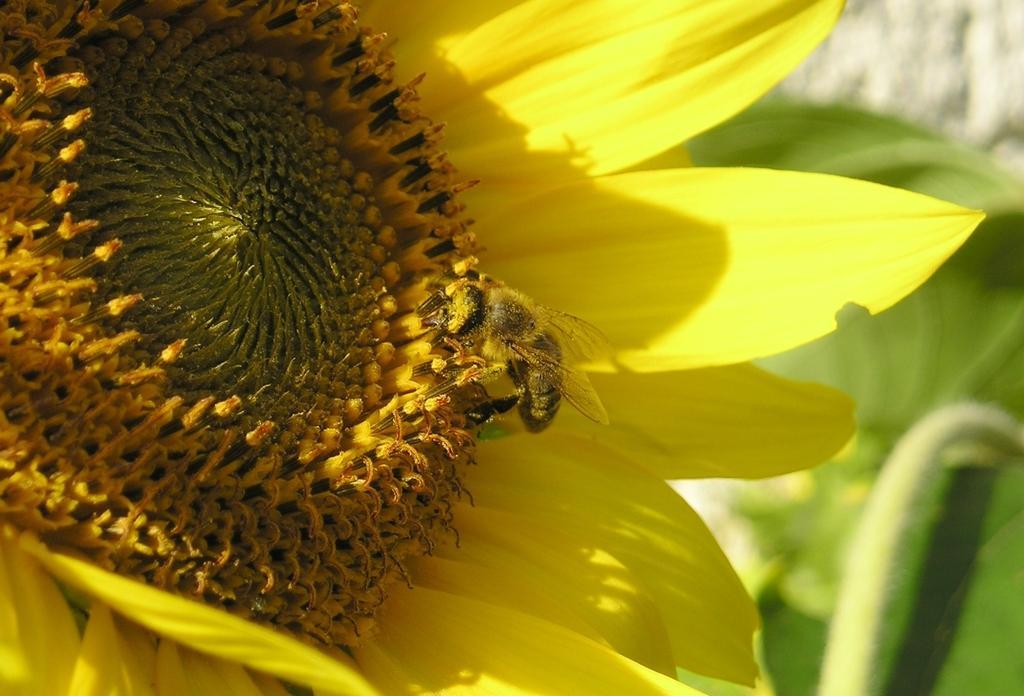Please provide a concise description of this image. In the picture we can see a sunflower which is yellow in color petals and on it we can see a bee sitting and in the background we can see leaves. 